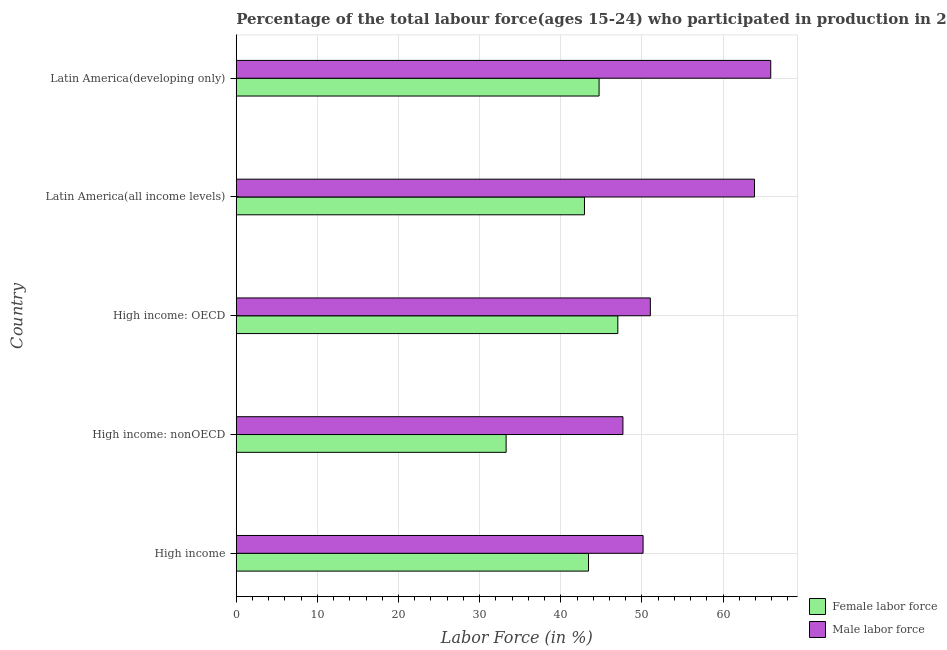How many different coloured bars are there?
Offer a terse response. 2. How many groups of bars are there?
Make the answer very short. 5. What is the label of the 1st group of bars from the top?
Your response must be concise. Latin America(developing only). In how many cases, is the number of bars for a given country not equal to the number of legend labels?
Your answer should be compact. 0. What is the percentage of male labour force in Latin America(developing only)?
Provide a succinct answer. 65.88. Across all countries, what is the maximum percentage of male labour force?
Give a very brief answer. 65.88. Across all countries, what is the minimum percentage of female labor force?
Provide a short and direct response. 33.26. In which country was the percentage of female labor force maximum?
Make the answer very short. High income: OECD. In which country was the percentage of male labour force minimum?
Your answer should be compact. High income: nonOECD. What is the total percentage of male labour force in the graph?
Keep it short and to the point. 278.6. What is the difference between the percentage of male labour force in High income: nonOECD and that in Latin America(all income levels)?
Ensure brevity in your answer.  -16.22. What is the difference between the percentage of female labor force in High income and the percentage of male labour force in Latin America(all income levels)?
Make the answer very short. -20.46. What is the average percentage of male labour force per country?
Ensure brevity in your answer.  55.72. What is the difference between the percentage of female labor force and percentage of male labour force in Latin America(developing only)?
Keep it short and to the point. -21.16. What is the ratio of the percentage of female labor force in High income: OECD to that in Latin America(developing only)?
Provide a succinct answer. 1.05. Is the percentage of male labour force in Latin America(all income levels) less than that in Latin America(developing only)?
Keep it short and to the point. Yes. Is the difference between the percentage of male labour force in High income: OECD and High income: nonOECD greater than the difference between the percentage of female labor force in High income: OECD and High income: nonOECD?
Give a very brief answer. No. What is the difference between the highest and the second highest percentage of female labor force?
Offer a very short reply. 2.31. What is the difference between the highest and the lowest percentage of male labour force?
Provide a short and direct response. 18.22. What does the 2nd bar from the top in Latin America(all income levels) represents?
Keep it short and to the point. Female labor force. What does the 1st bar from the bottom in Latin America(developing only) represents?
Give a very brief answer. Female labor force. How many bars are there?
Give a very brief answer. 10. Are all the bars in the graph horizontal?
Your answer should be very brief. Yes. How many countries are there in the graph?
Offer a very short reply. 5. Does the graph contain any zero values?
Keep it short and to the point. No. Where does the legend appear in the graph?
Your answer should be very brief. Bottom right. How are the legend labels stacked?
Your answer should be compact. Vertical. What is the title of the graph?
Keep it short and to the point. Percentage of the total labour force(ages 15-24) who participated in production in 2008. What is the label or title of the Y-axis?
Give a very brief answer. Country. What is the Labor Force (in %) of Female labor force in High income?
Keep it short and to the point. 43.42. What is the Labor Force (in %) of Male labor force in High income?
Your answer should be very brief. 50.14. What is the Labor Force (in %) in Female labor force in High income: nonOECD?
Provide a succinct answer. 33.26. What is the Labor Force (in %) in Male labor force in High income: nonOECD?
Ensure brevity in your answer.  47.66. What is the Labor Force (in %) of Female labor force in High income: OECD?
Make the answer very short. 47.03. What is the Labor Force (in %) in Male labor force in High income: OECD?
Provide a short and direct response. 51.04. What is the Labor Force (in %) in Female labor force in Latin America(all income levels)?
Ensure brevity in your answer.  42.92. What is the Labor Force (in %) in Male labor force in Latin America(all income levels)?
Provide a succinct answer. 63.88. What is the Labor Force (in %) in Female labor force in Latin America(developing only)?
Offer a very short reply. 44.72. What is the Labor Force (in %) in Male labor force in Latin America(developing only)?
Keep it short and to the point. 65.88. Across all countries, what is the maximum Labor Force (in %) of Female labor force?
Keep it short and to the point. 47.03. Across all countries, what is the maximum Labor Force (in %) in Male labor force?
Ensure brevity in your answer.  65.88. Across all countries, what is the minimum Labor Force (in %) of Female labor force?
Provide a succinct answer. 33.26. Across all countries, what is the minimum Labor Force (in %) in Male labor force?
Make the answer very short. 47.66. What is the total Labor Force (in %) in Female labor force in the graph?
Provide a succinct answer. 211.36. What is the total Labor Force (in %) of Male labor force in the graph?
Make the answer very short. 278.6. What is the difference between the Labor Force (in %) of Female labor force in High income and that in High income: nonOECD?
Provide a succinct answer. 10.16. What is the difference between the Labor Force (in %) of Male labor force in High income and that in High income: nonOECD?
Your answer should be compact. 2.48. What is the difference between the Labor Force (in %) of Female labor force in High income and that in High income: OECD?
Ensure brevity in your answer.  -3.61. What is the difference between the Labor Force (in %) of Male labor force in High income and that in High income: OECD?
Your answer should be compact. -0.9. What is the difference between the Labor Force (in %) of Female labor force in High income and that in Latin America(all income levels)?
Give a very brief answer. 0.5. What is the difference between the Labor Force (in %) in Male labor force in High income and that in Latin America(all income levels)?
Your answer should be compact. -13.73. What is the difference between the Labor Force (in %) of Female labor force in High income and that in Latin America(developing only)?
Offer a terse response. -1.3. What is the difference between the Labor Force (in %) of Male labor force in High income and that in Latin America(developing only)?
Your response must be concise. -15.74. What is the difference between the Labor Force (in %) of Female labor force in High income: nonOECD and that in High income: OECD?
Offer a very short reply. -13.77. What is the difference between the Labor Force (in %) in Male labor force in High income: nonOECD and that in High income: OECD?
Give a very brief answer. -3.38. What is the difference between the Labor Force (in %) of Female labor force in High income: nonOECD and that in Latin America(all income levels)?
Offer a terse response. -9.66. What is the difference between the Labor Force (in %) of Male labor force in High income: nonOECD and that in Latin America(all income levels)?
Make the answer very short. -16.22. What is the difference between the Labor Force (in %) in Female labor force in High income: nonOECD and that in Latin America(developing only)?
Make the answer very short. -11.46. What is the difference between the Labor Force (in %) of Male labor force in High income: nonOECD and that in Latin America(developing only)?
Provide a short and direct response. -18.22. What is the difference between the Labor Force (in %) of Female labor force in High income: OECD and that in Latin America(all income levels)?
Your answer should be very brief. 4.11. What is the difference between the Labor Force (in %) in Male labor force in High income: OECD and that in Latin America(all income levels)?
Keep it short and to the point. -12.84. What is the difference between the Labor Force (in %) in Female labor force in High income: OECD and that in Latin America(developing only)?
Your answer should be very brief. 2.31. What is the difference between the Labor Force (in %) in Male labor force in High income: OECD and that in Latin America(developing only)?
Offer a terse response. -14.84. What is the difference between the Labor Force (in %) in Female labor force in Latin America(all income levels) and that in Latin America(developing only)?
Make the answer very short. -1.8. What is the difference between the Labor Force (in %) in Male labor force in Latin America(all income levels) and that in Latin America(developing only)?
Your response must be concise. -2. What is the difference between the Labor Force (in %) of Female labor force in High income and the Labor Force (in %) of Male labor force in High income: nonOECD?
Your response must be concise. -4.24. What is the difference between the Labor Force (in %) in Female labor force in High income and the Labor Force (in %) in Male labor force in High income: OECD?
Provide a short and direct response. -7.62. What is the difference between the Labor Force (in %) in Female labor force in High income and the Labor Force (in %) in Male labor force in Latin America(all income levels)?
Give a very brief answer. -20.46. What is the difference between the Labor Force (in %) in Female labor force in High income and the Labor Force (in %) in Male labor force in Latin America(developing only)?
Provide a short and direct response. -22.46. What is the difference between the Labor Force (in %) of Female labor force in High income: nonOECD and the Labor Force (in %) of Male labor force in High income: OECD?
Ensure brevity in your answer.  -17.78. What is the difference between the Labor Force (in %) in Female labor force in High income: nonOECD and the Labor Force (in %) in Male labor force in Latin America(all income levels)?
Your response must be concise. -30.62. What is the difference between the Labor Force (in %) of Female labor force in High income: nonOECD and the Labor Force (in %) of Male labor force in Latin America(developing only)?
Your answer should be compact. -32.62. What is the difference between the Labor Force (in %) in Female labor force in High income: OECD and the Labor Force (in %) in Male labor force in Latin America(all income levels)?
Ensure brevity in your answer.  -16.85. What is the difference between the Labor Force (in %) of Female labor force in High income: OECD and the Labor Force (in %) of Male labor force in Latin America(developing only)?
Your response must be concise. -18.85. What is the difference between the Labor Force (in %) of Female labor force in Latin America(all income levels) and the Labor Force (in %) of Male labor force in Latin America(developing only)?
Provide a succinct answer. -22.96. What is the average Labor Force (in %) in Female labor force per country?
Give a very brief answer. 42.27. What is the average Labor Force (in %) of Male labor force per country?
Provide a succinct answer. 55.72. What is the difference between the Labor Force (in %) of Female labor force and Labor Force (in %) of Male labor force in High income?
Ensure brevity in your answer.  -6.72. What is the difference between the Labor Force (in %) of Female labor force and Labor Force (in %) of Male labor force in High income: nonOECD?
Your answer should be very brief. -14.4. What is the difference between the Labor Force (in %) of Female labor force and Labor Force (in %) of Male labor force in High income: OECD?
Ensure brevity in your answer.  -4.01. What is the difference between the Labor Force (in %) in Female labor force and Labor Force (in %) in Male labor force in Latin America(all income levels)?
Your answer should be compact. -20.96. What is the difference between the Labor Force (in %) in Female labor force and Labor Force (in %) in Male labor force in Latin America(developing only)?
Keep it short and to the point. -21.16. What is the ratio of the Labor Force (in %) of Female labor force in High income to that in High income: nonOECD?
Provide a succinct answer. 1.31. What is the ratio of the Labor Force (in %) in Male labor force in High income to that in High income: nonOECD?
Your answer should be compact. 1.05. What is the ratio of the Labor Force (in %) in Female labor force in High income to that in High income: OECD?
Provide a succinct answer. 0.92. What is the ratio of the Labor Force (in %) of Male labor force in High income to that in High income: OECD?
Offer a terse response. 0.98. What is the ratio of the Labor Force (in %) of Female labor force in High income to that in Latin America(all income levels)?
Make the answer very short. 1.01. What is the ratio of the Labor Force (in %) of Male labor force in High income to that in Latin America(all income levels)?
Provide a succinct answer. 0.79. What is the ratio of the Labor Force (in %) of Female labor force in High income to that in Latin America(developing only)?
Your answer should be very brief. 0.97. What is the ratio of the Labor Force (in %) of Male labor force in High income to that in Latin America(developing only)?
Make the answer very short. 0.76. What is the ratio of the Labor Force (in %) of Female labor force in High income: nonOECD to that in High income: OECD?
Keep it short and to the point. 0.71. What is the ratio of the Labor Force (in %) in Male labor force in High income: nonOECD to that in High income: OECD?
Provide a succinct answer. 0.93. What is the ratio of the Labor Force (in %) of Female labor force in High income: nonOECD to that in Latin America(all income levels)?
Your answer should be very brief. 0.78. What is the ratio of the Labor Force (in %) in Male labor force in High income: nonOECD to that in Latin America(all income levels)?
Make the answer very short. 0.75. What is the ratio of the Labor Force (in %) of Female labor force in High income: nonOECD to that in Latin America(developing only)?
Your answer should be compact. 0.74. What is the ratio of the Labor Force (in %) of Male labor force in High income: nonOECD to that in Latin America(developing only)?
Offer a terse response. 0.72. What is the ratio of the Labor Force (in %) of Female labor force in High income: OECD to that in Latin America(all income levels)?
Your answer should be very brief. 1.1. What is the ratio of the Labor Force (in %) of Male labor force in High income: OECD to that in Latin America(all income levels)?
Ensure brevity in your answer.  0.8. What is the ratio of the Labor Force (in %) of Female labor force in High income: OECD to that in Latin America(developing only)?
Your answer should be very brief. 1.05. What is the ratio of the Labor Force (in %) of Male labor force in High income: OECD to that in Latin America(developing only)?
Give a very brief answer. 0.77. What is the ratio of the Labor Force (in %) in Female labor force in Latin America(all income levels) to that in Latin America(developing only)?
Give a very brief answer. 0.96. What is the ratio of the Labor Force (in %) of Male labor force in Latin America(all income levels) to that in Latin America(developing only)?
Offer a terse response. 0.97. What is the difference between the highest and the second highest Labor Force (in %) of Female labor force?
Give a very brief answer. 2.31. What is the difference between the highest and the second highest Labor Force (in %) of Male labor force?
Your answer should be very brief. 2. What is the difference between the highest and the lowest Labor Force (in %) of Female labor force?
Your answer should be compact. 13.77. What is the difference between the highest and the lowest Labor Force (in %) in Male labor force?
Your response must be concise. 18.22. 